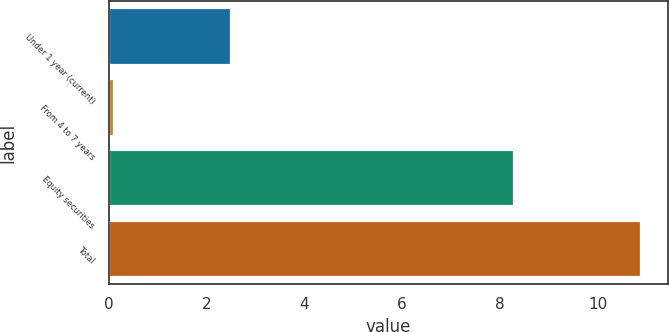Convert chart to OTSL. <chart><loc_0><loc_0><loc_500><loc_500><bar_chart><fcel>Under 1 year (current)<fcel>From 4 to 7 years<fcel>Equity securities<fcel>Total<nl><fcel>2.5<fcel>0.1<fcel>8.3<fcel>10.9<nl></chart> 